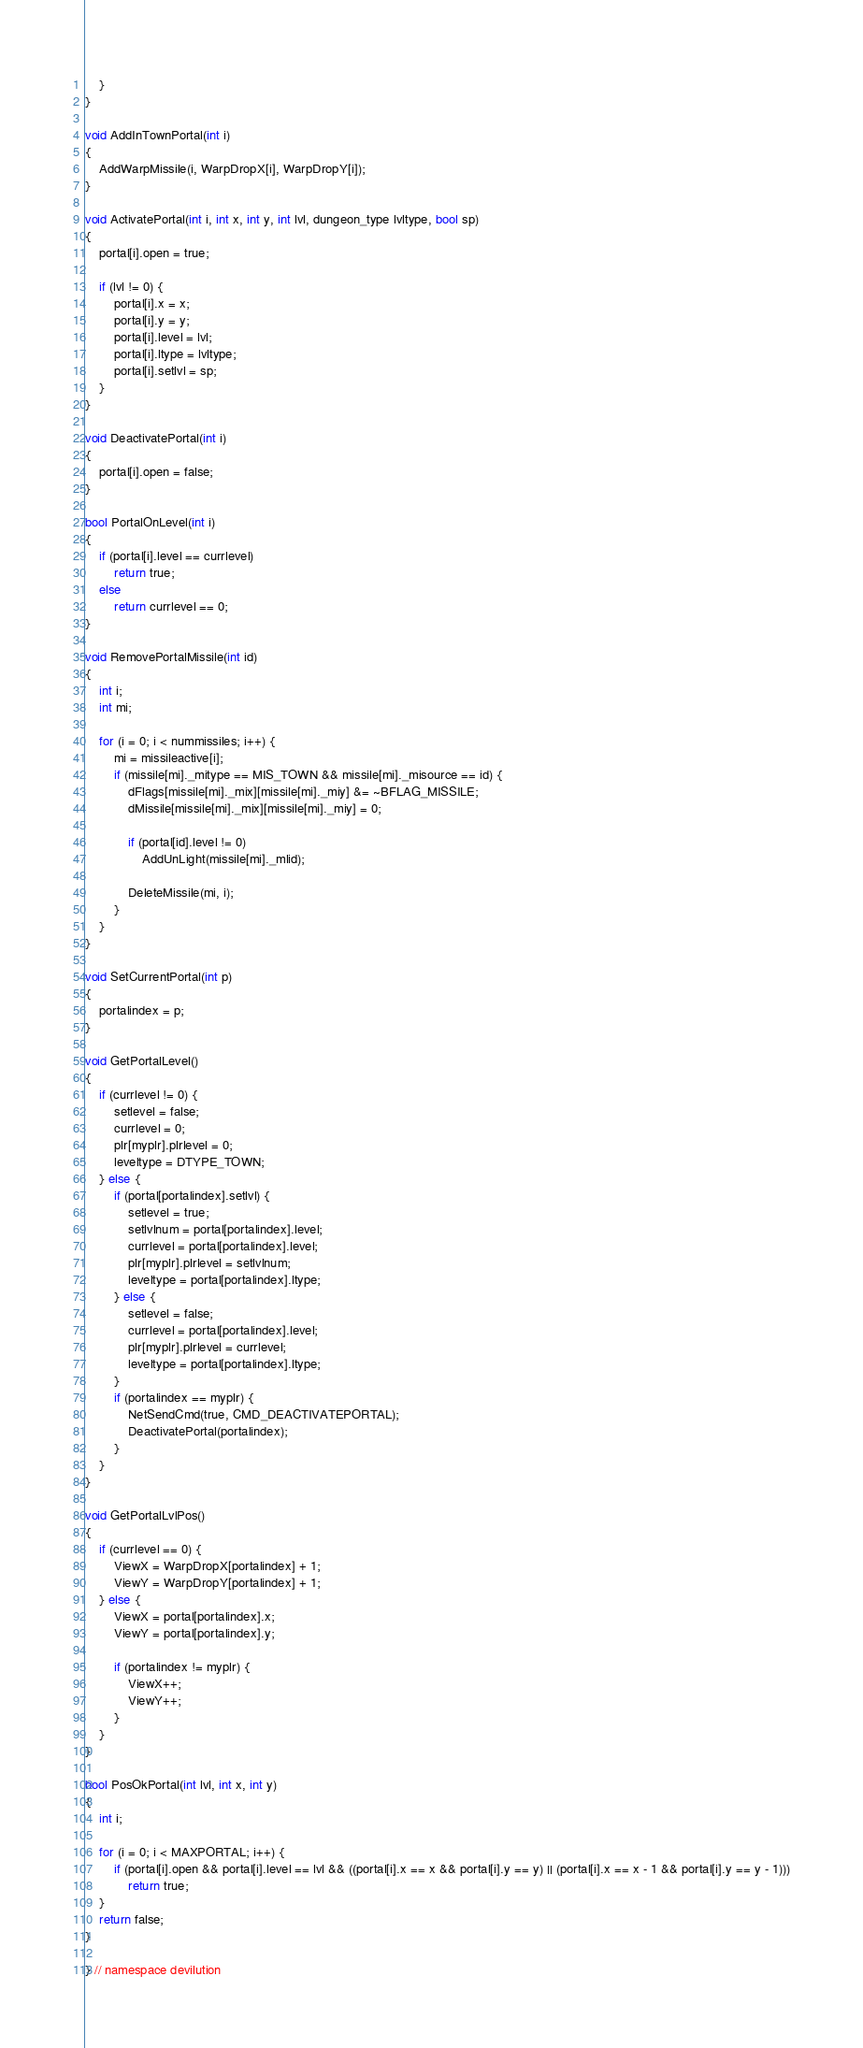Convert code to text. <code><loc_0><loc_0><loc_500><loc_500><_C++_>	}
}

void AddInTownPortal(int i)
{
	AddWarpMissile(i, WarpDropX[i], WarpDropY[i]);
}

void ActivatePortal(int i, int x, int y, int lvl, dungeon_type lvltype, bool sp)
{
	portal[i].open = true;

	if (lvl != 0) {
		portal[i].x = x;
		portal[i].y = y;
		portal[i].level = lvl;
		portal[i].ltype = lvltype;
		portal[i].setlvl = sp;
	}
}

void DeactivatePortal(int i)
{
	portal[i].open = false;
}

bool PortalOnLevel(int i)
{
	if (portal[i].level == currlevel)
		return true;
	else
		return currlevel == 0;
}

void RemovePortalMissile(int id)
{
	int i;
	int mi;

	for (i = 0; i < nummissiles; i++) {
		mi = missileactive[i];
		if (missile[mi]._mitype == MIS_TOWN && missile[mi]._misource == id) {
			dFlags[missile[mi]._mix][missile[mi]._miy] &= ~BFLAG_MISSILE;
			dMissile[missile[mi]._mix][missile[mi]._miy] = 0;

			if (portal[id].level != 0)
				AddUnLight(missile[mi]._mlid);

			DeleteMissile(mi, i);
		}
	}
}

void SetCurrentPortal(int p)
{
	portalindex = p;
}

void GetPortalLevel()
{
	if (currlevel != 0) {
		setlevel = false;
		currlevel = 0;
		plr[myplr].plrlevel = 0;
		leveltype = DTYPE_TOWN;
	} else {
		if (portal[portalindex].setlvl) {
			setlevel = true;
			setlvlnum = portal[portalindex].level;
			currlevel = portal[portalindex].level;
			plr[myplr].plrlevel = setlvlnum;
			leveltype = portal[portalindex].ltype;
		} else {
			setlevel = false;
			currlevel = portal[portalindex].level;
			plr[myplr].plrlevel = currlevel;
			leveltype = portal[portalindex].ltype;
		}
		if (portalindex == myplr) {
			NetSendCmd(true, CMD_DEACTIVATEPORTAL);
			DeactivatePortal(portalindex);
		}
	}
}

void GetPortalLvlPos()
{
	if (currlevel == 0) {
		ViewX = WarpDropX[portalindex] + 1;
		ViewY = WarpDropY[portalindex] + 1;
	} else {
		ViewX = portal[portalindex].x;
		ViewY = portal[portalindex].y;

		if (portalindex != myplr) {
			ViewX++;
			ViewY++;
		}
	}
}

bool PosOkPortal(int lvl, int x, int y)
{
	int i;

	for (i = 0; i < MAXPORTAL; i++) {
		if (portal[i].open && portal[i].level == lvl && ((portal[i].x == x && portal[i].y == y) || (portal[i].x == x - 1 && portal[i].y == y - 1)))
			return true;
	}
	return false;
}

} // namespace devilution
</code> 